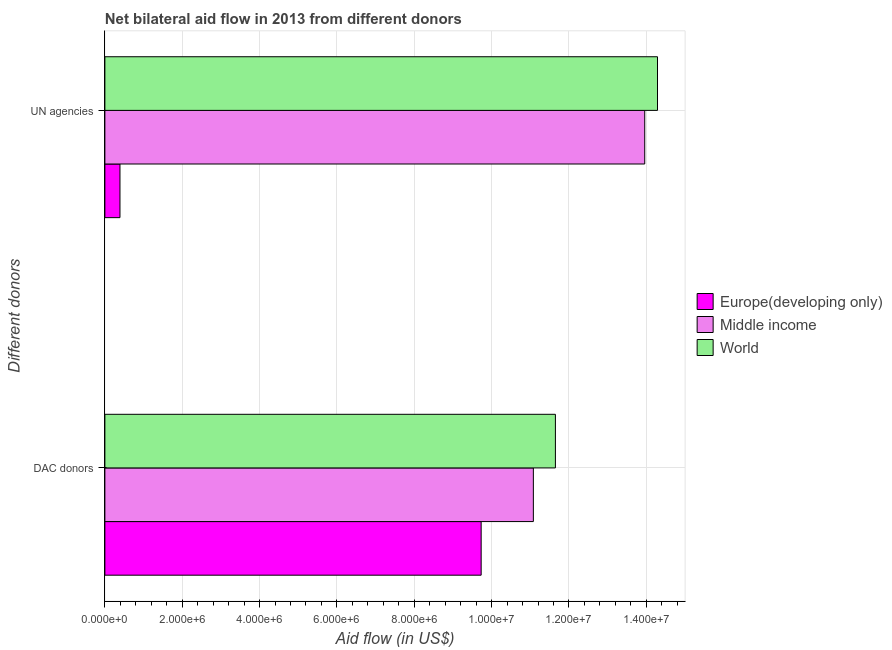How many different coloured bars are there?
Give a very brief answer. 3. How many groups of bars are there?
Ensure brevity in your answer.  2. How many bars are there on the 2nd tick from the bottom?
Your response must be concise. 3. What is the label of the 2nd group of bars from the top?
Your response must be concise. DAC donors. What is the aid flow from dac donors in Europe(developing only)?
Ensure brevity in your answer.  9.73e+06. Across all countries, what is the maximum aid flow from un agencies?
Ensure brevity in your answer.  1.43e+07. Across all countries, what is the minimum aid flow from dac donors?
Provide a short and direct response. 9.73e+06. In which country was the aid flow from un agencies minimum?
Your answer should be compact. Europe(developing only). What is the total aid flow from un agencies in the graph?
Keep it short and to the point. 2.86e+07. What is the difference between the aid flow from un agencies in World and that in Europe(developing only)?
Keep it short and to the point. 1.39e+07. What is the difference between the aid flow from un agencies in Europe(developing only) and the aid flow from dac donors in Middle income?
Make the answer very short. -1.07e+07. What is the average aid flow from un agencies per country?
Provide a short and direct response. 9.55e+06. What is the difference between the aid flow from un agencies and aid flow from dac donors in Middle income?
Ensure brevity in your answer.  2.88e+06. What is the ratio of the aid flow from dac donors in Middle income to that in World?
Provide a succinct answer. 0.95. Is the aid flow from dac donors in Europe(developing only) less than that in World?
Your answer should be compact. Yes. What does the 1st bar from the bottom in DAC donors represents?
Your answer should be compact. Europe(developing only). How many bars are there?
Offer a terse response. 6. Are all the bars in the graph horizontal?
Your answer should be compact. Yes. What is the difference between two consecutive major ticks on the X-axis?
Provide a succinct answer. 2.00e+06. Are the values on the major ticks of X-axis written in scientific E-notation?
Your response must be concise. Yes. Does the graph contain any zero values?
Provide a succinct answer. No. Does the graph contain grids?
Provide a short and direct response. Yes. How are the legend labels stacked?
Ensure brevity in your answer.  Vertical. What is the title of the graph?
Ensure brevity in your answer.  Net bilateral aid flow in 2013 from different donors. What is the label or title of the X-axis?
Your response must be concise. Aid flow (in US$). What is the label or title of the Y-axis?
Make the answer very short. Different donors. What is the Aid flow (in US$) of Europe(developing only) in DAC donors?
Keep it short and to the point. 9.73e+06. What is the Aid flow (in US$) in Middle income in DAC donors?
Your answer should be very brief. 1.11e+07. What is the Aid flow (in US$) of World in DAC donors?
Provide a succinct answer. 1.16e+07. What is the Aid flow (in US$) in Middle income in UN agencies?
Your response must be concise. 1.40e+07. What is the Aid flow (in US$) in World in UN agencies?
Your answer should be compact. 1.43e+07. Across all Different donors, what is the maximum Aid flow (in US$) of Europe(developing only)?
Make the answer very short. 9.73e+06. Across all Different donors, what is the maximum Aid flow (in US$) of Middle income?
Provide a short and direct response. 1.40e+07. Across all Different donors, what is the maximum Aid flow (in US$) in World?
Offer a very short reply. 1.43e+07. Across all Different donors, what is the minimum Aid flow (in US$) in Europe(developing only)?
Provide a succinct answer. 3.90e+05. Across all Different donors, what is the minimum Aid flow (in US$) of Middle income?
Your response must be concise. 1.11e+07. Across all Different donors, what is the minimum Aid flow (in US$) of World?
Offer a terse response. 1.16e+07. What is the total Aid flow (in US$) in Europe(developing only) in the graph?
Make the answer very short. 1.01e+07. What is the total Aid flow (in US$) in Middle income in the graph?
Keep it short and to the point. 2.50e+07. What is the total Aid flow (in US$) in World in the graph?
Make the answer very short. 2.59e+07. What is the difference between the Aid flow (in US$) of Europe(developing only) in DAC donors and that in UN agencies?
Ensure brevity in your answer.  9.34e+06. What is the difference between the Aid flow (in US$) of Middle income in DAC donors and that in UN agencies?
Your response must be concise. -2.88e+06. What is the difference between the Aid flow (in US$) in World in DAC donors and that in UN agencies?
Keep it short and to the point. -2.64e+06. What is the difference between the Aid flow (in US$) of Europe(developing only) in DAC donors and the Aid flow (in US$) of Middle income in UN agencies?
Provide a short and direct response. -4.23e+06. What is the difference between the Aid flow (in US$) in Europe(developing only) in DAC donors and the Aid flow (in US$) in World in UN agencies?
Give a very brief answer. -4.56e+06. What is the difference between the Aid flow (in US$) of Middle income in DAC donors and the Aid flow (in US$) of World in UN agencies?
Make the answer very short. -3.21e+06. What is the average Aid flow (in US$) in Europe(developing only) per Different donors?
Your answer should be very brief. 5.06e+06. What is the average Aid flow (in US$) of Middle income per Different donors?
Provide a succinct answer. 1.25e+07. What is the average Aid flow (in US$) of World per Different donors?
Keep it short and to the point. 1.30e+07. What is the difference between the Aid flow (in US$) of Europe(developing only) and Aid flow (in US$) of Middle income in DAC donors?
Make the answer very short. -1.35e+06. What is the difference between the Aid flow (in US$) in Europe(developing only) and Aid flow (in US$) in World in DAC donors?
Provide a succinct answer. -1.92e+06. What is the difference between the Aid flow (in US$) of Middle income and Aid flow (in US$) of World in DAC donors?
Keep it short and to the point. -5.70e+05. What is the difference between the Aid flow (in US$) of Europe(developing only) and Aid flow (in US$) of Middle income in UN agencies?
Offer a very short reply. -1.36e+07. What is the difference between the Aid flow (in US$) in Europe(developing only) and Aid flow (in US$) in World in UN agencies?
Your answer should be compact. -1.39e+07. What is the difference between the Aid flow (in US$) in Middle income and Aid flow (in US$) in World in UN agencies?
Your response must be concise. -3.30e+05. What is the ratio of the Aid flow (in US$) in Europe(developing only) in DAC donors to that in UN agencies?
Your answer should be compact. 24.95. What is the ratio of the Aid flow (in US$) in Middle income in DAC donors to that in UN agencies?
Give a very brief answer. 0.79. What is the ratio of the Aid flow (in US$) of World in DAC donors to that in UN agencies?
Your response must be concise. 0.82. What is the difference between the highest and the second highest Aid flow (in US$) in Europe(developing only)?
Provide a succinct answer. 9.34e+06. What is the difference between the highest and the second highest Aid flow (in US$) of Middle income?
Make the answer very short. 2.88e+06. What is the difference between the highest and the second highest Aid flow (in US$) of World?
Your answer should be compact. 2.64e+06. What is the difference between the highest and the lowest Aid flow (in US$) of Europe(developing only)?
Offer a very short reply. 9.34e+06. What is the difference between the highest and the lowest Aid flow (in US$) in Middle income?
Your answer should be very brief. 2.88e+06. What is the difference between the highest and the lowest Aid flow (in US$) in World?
Your response must be concise. 2.64e+06. 